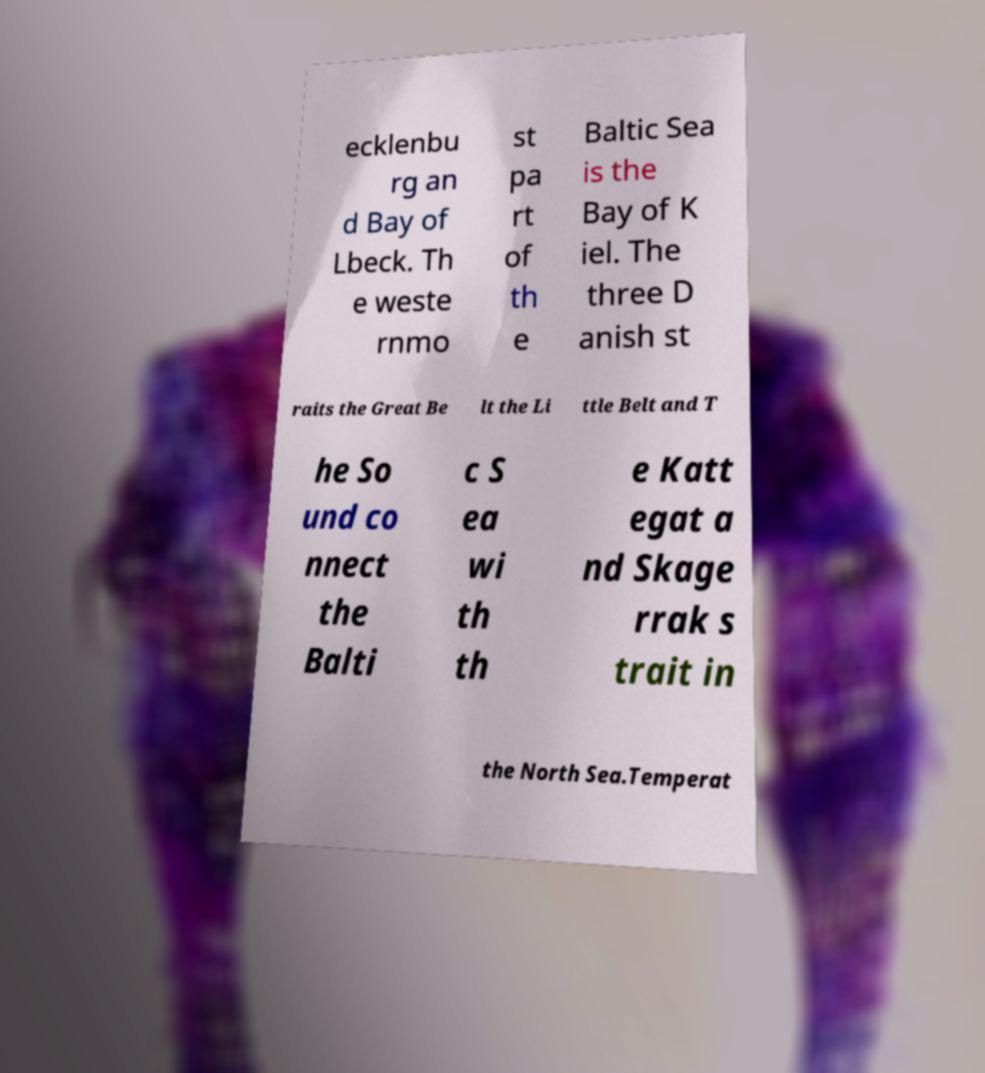Can you read and provide the text displayed in the image?This photo seems to have some interesting text. Can you extract and type it out for me? ecklenbu rg an d Bay of Lbeck. Th e weste rnmo st pa rt of th e Baltic Sea is the Bay of K iel. The three D anish st raits the Great Be lt the Li ttle Belt and T he So und co nnect the Balti c S ea wi th th e Katt egat a nd Skage rrak s trait in the North Sea.Temperat 